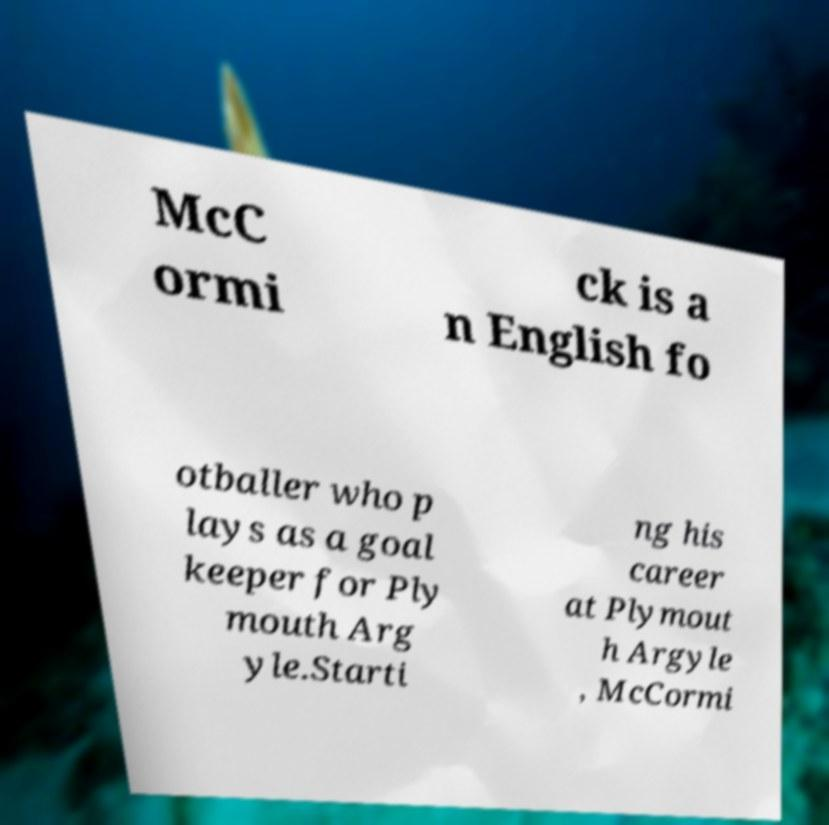I need the written content from this picture converted into text. Can you do that? McC ormi ck is a n English fo otballer who p lays as a goal keeper for Ply mouth Arg yle.Starti ng his career at Plymout h Argyle , McCormi 